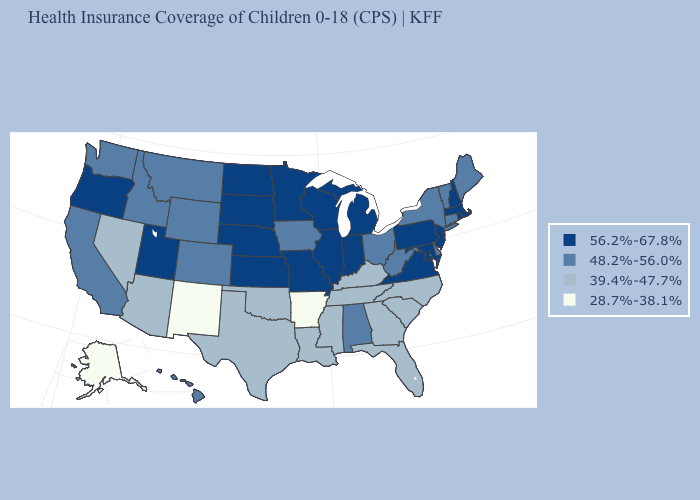Does Utah have the lowest value in the West?
Concise answer only. No. Among the states that border Virginia , does Maryland have the highest value?
Concise answer only. Yes. Does New Mexico have the lowest value in the USA?
Quick response, please. Yes. Among the states that border Missouri , which have the lowest value?
Keep it brief. Arkansas. Which states hav the highest value in the West?
Short answer required. Oregon, Utah. What is the highest value in the USA?
Be succinct. 56.2%-67.8%. Which states have the highest value in the USA?
Concise answer only. Illinois, Indiana, Kansas, Maryland, Massachusetts, Michigan, Minnesota, Missouri, Nebraska, New Hampshire, New Jersey, North Dakota, Oregon, Pennsylvania, Rhode Island, South Dakota, Utah, Virginia, Wisconsin. Name the states that have a value in the range 48.2%-56.0%?
Answer briefly. Alabama, California, Colorado, Connecticut, Delaware, Hawaii, Idaho, Iowa, Maine, Montana, New York, Ohio, Vermont, Washington, West Virginia, Wyoming. How many symbols are there in the legend?
Be succinct. 4. Among the states that border Wyoming , does Utah have the highest value?
Write a very short answer. Yes. What is the value of Massachusetts?
Write a very short answer. 56.2%-67.8%. Name the states that have a value in the range 28.7%-38.1%?
Be succinct. Alaska, Arkansas, New Mexico. Which states hav the highest value in the Northeast?
Concise answer only. Massachusetts, New Hampshire, New Jersey, Pennsylvania, Rhode Island. Does Colorado have a lower value than Minnesota?
Answer briefly. Yes. What is the value of Texas?
Keep it brief. 39.4%-47.7%. 